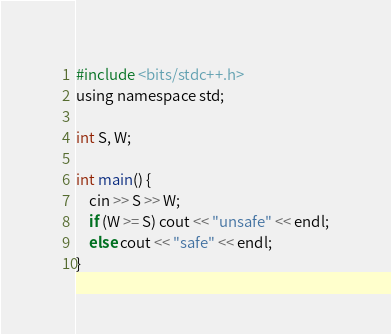<code> <loc_0><loc_0><loc_500><loc_500><_C_>#include <bits/stdc++.h>
using namespace std;

int S, W;

int main() {
    cin >> S >> W;
    if (W >= S) cout << "unsafe" << endl;
    else cout << "safe" << endl;
}</code> 